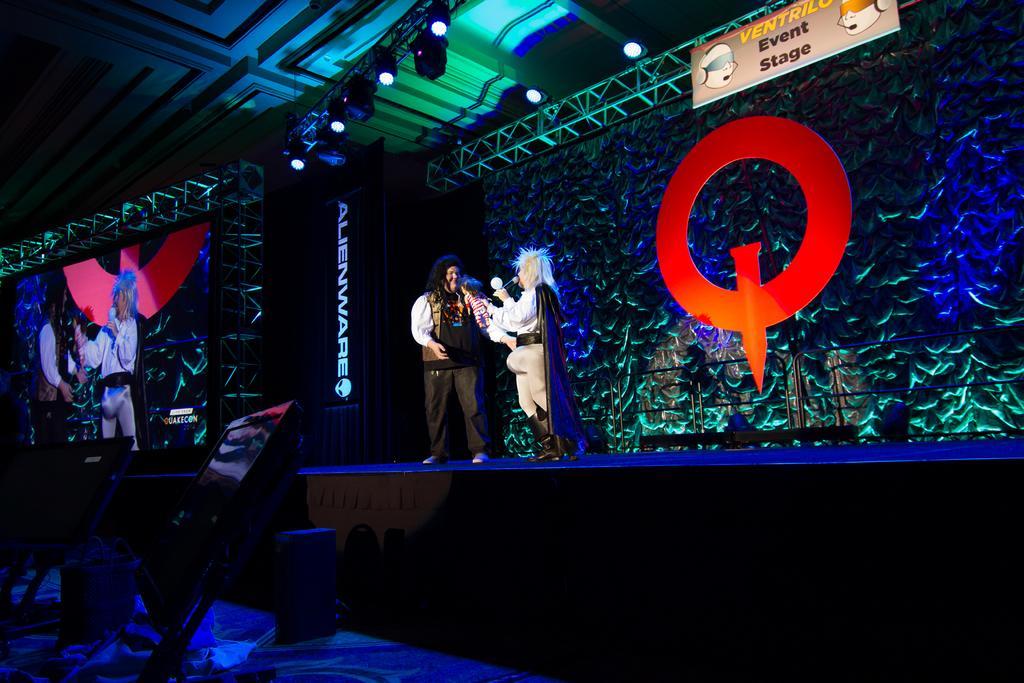Could you give a brief overview of what you see in this image? In the image we can see there are people standing on the stage and there are speaker boxes kept on the ground. On the other side on the stage there is a projector screen and people are standing on the stage are seen. There are lightings on the top and there is a hoarding on the iron poles on which its written ¨Event Stage¨. 